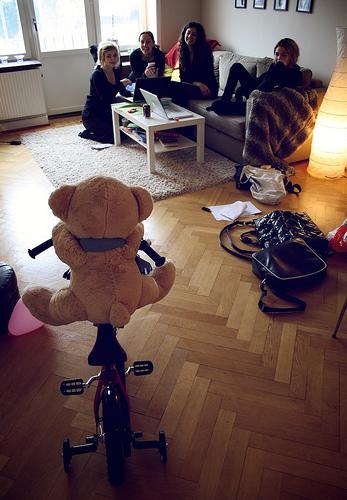Is the teddy bear riding a bike?
Give a very brief answer. Yes. What type of material is on the floor?
Short answer required. Wood. Do you think the people in this scene are a family?
Short answer required. Yes. 